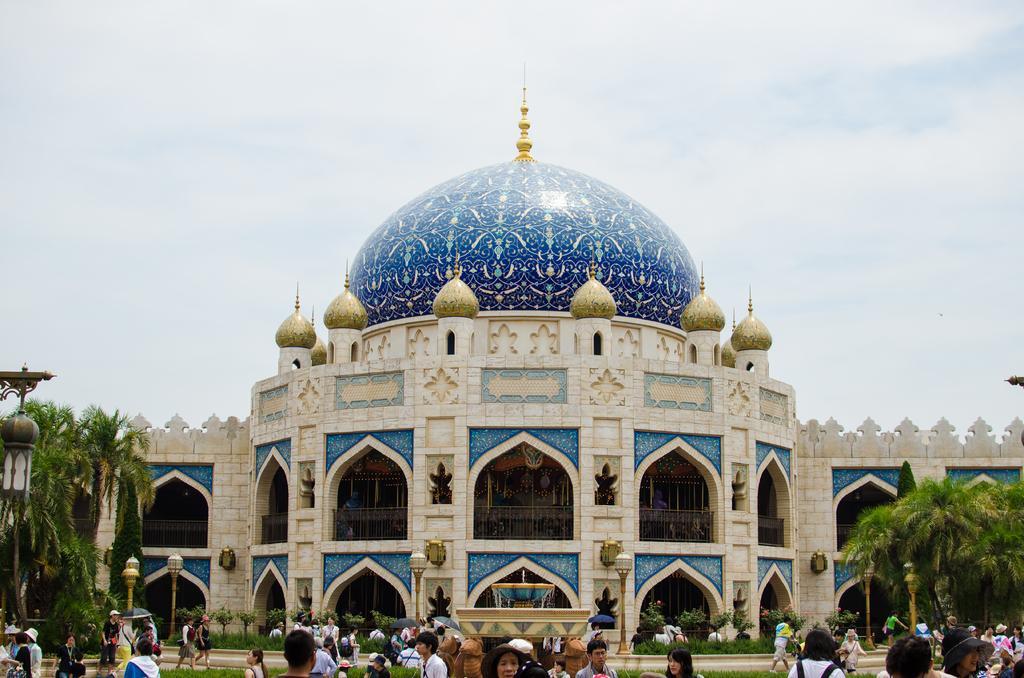How would you summarize this image in a sentence or two? It is the picture of Tokyo Disney sea, many visitors were walking around the area in front of the building and there is a fountain in the middle, on the either side of the building there are few trees. 